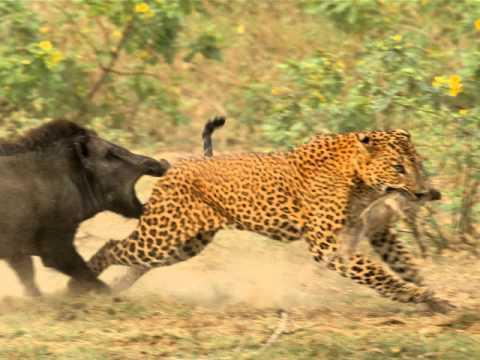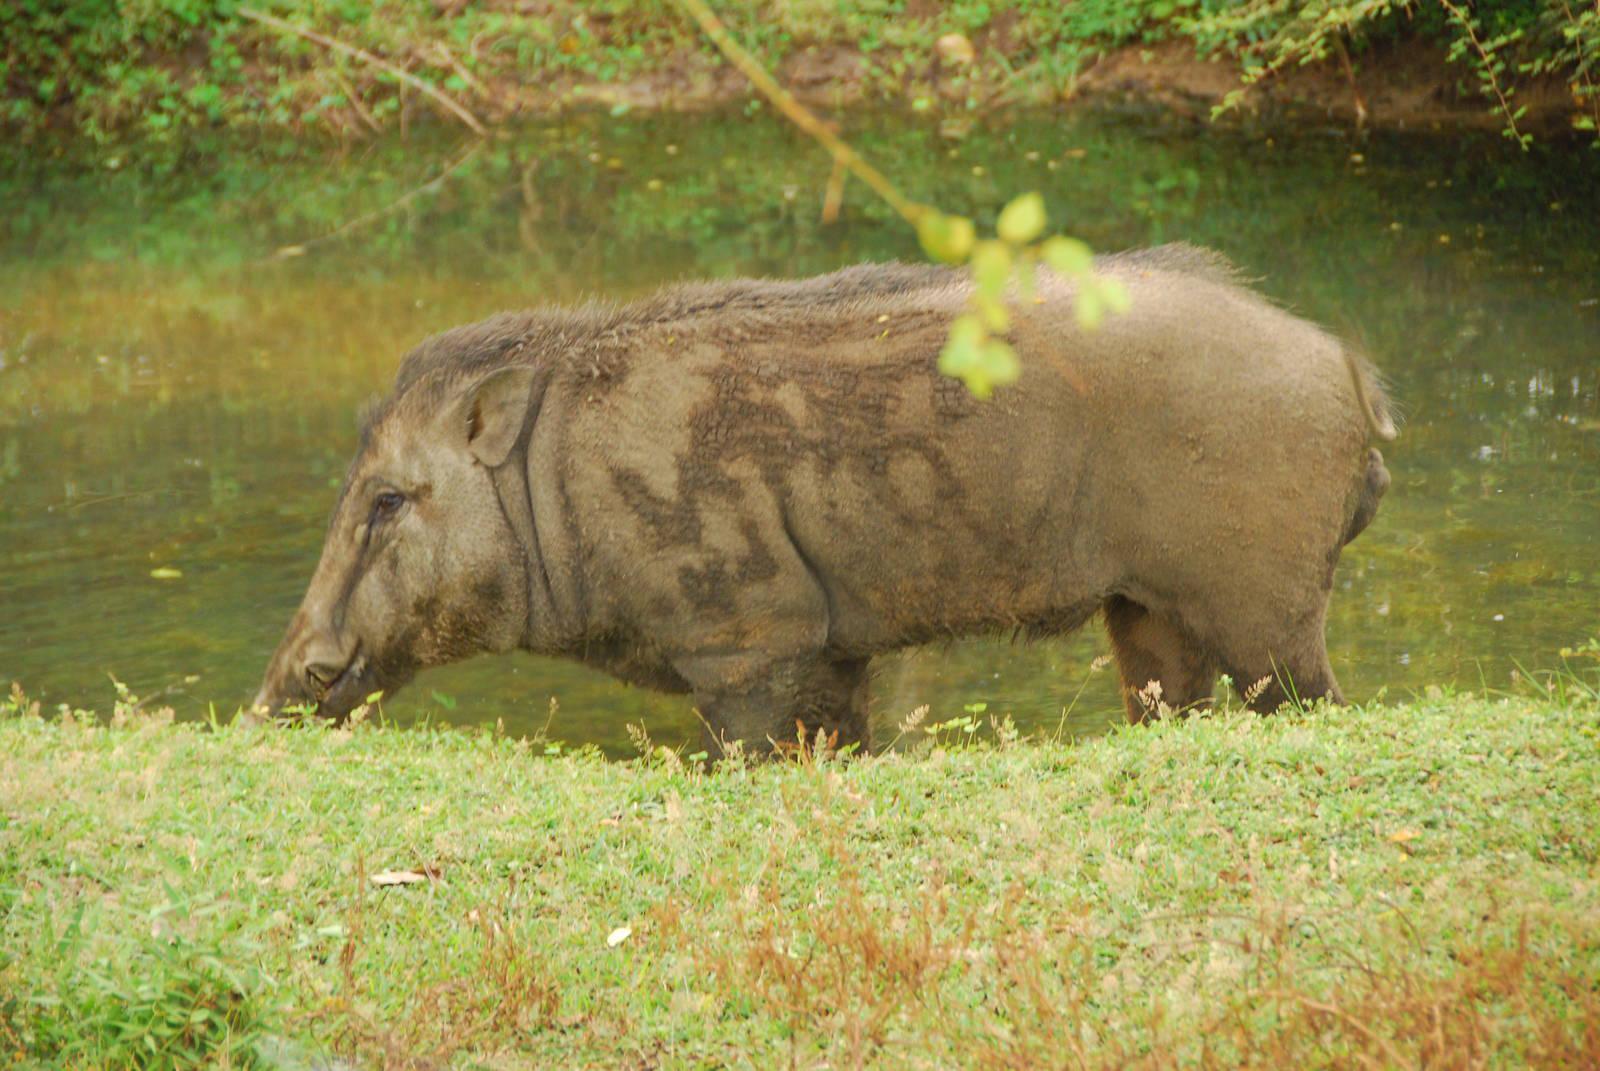The first image is the image on the left, the second image is the image on the right. Examine the images to the left and right. Is the description "An image shows a boar with its spotted deer-like prey animal." accurate? Answer yes or no. No. The first image is the image on the left, the second image is the image on the right. For the images displayed, is the sentence "a hog is standing in water." factually correct? Answer yes or no. Yes. 